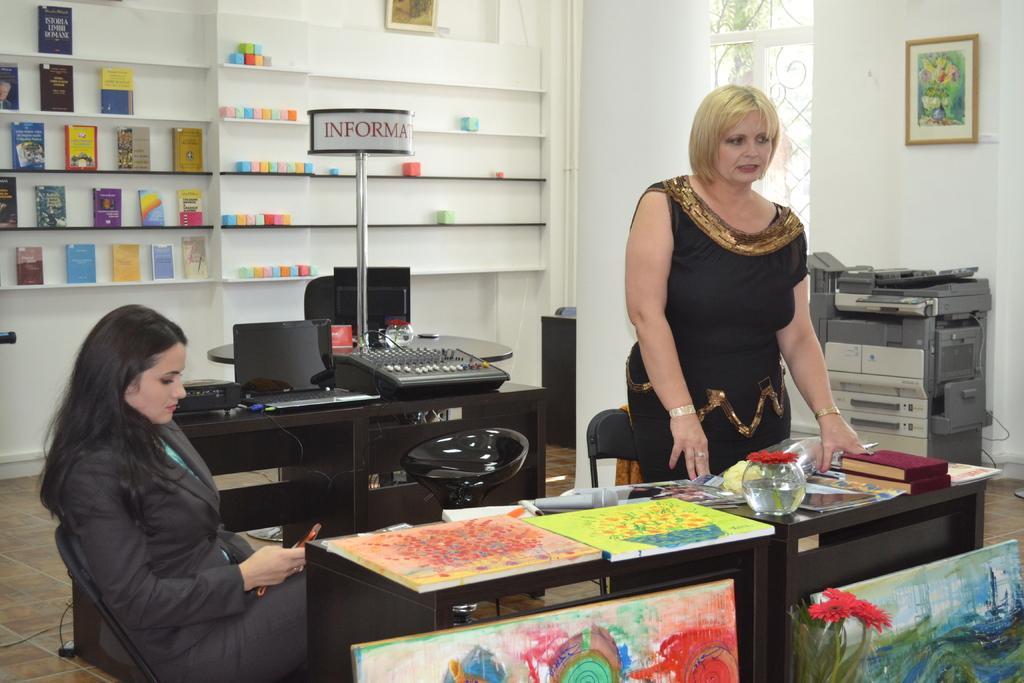In one or two sentences, can you explain what this image depicts? in this picture we can see two women, one woman is standing and other is sitting,we can also see table ,there are different items present , we can see the shelf attached to the wall ,in the shelf we can see number of books. 